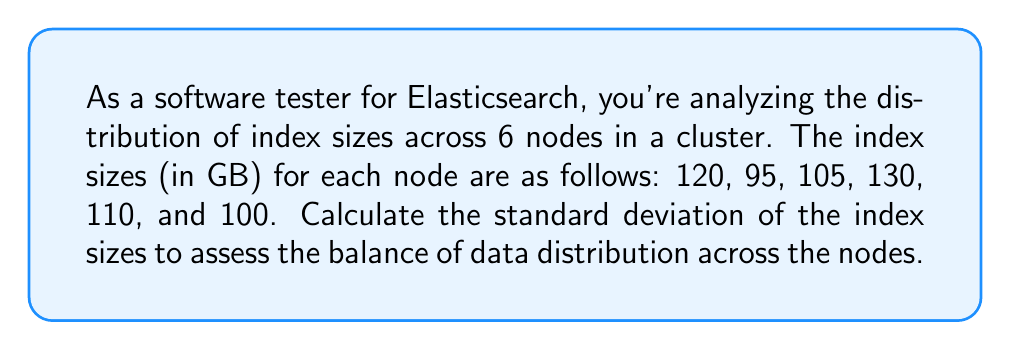Provide a solution to this math problem. To calculate the standard deviation, we'll follow these steps:

1. Calculate the mean (average) of the index sizes:
   $$\bar{x} = \frac{\sum_{i=1}^{n} x_i}{n} = \frac{120 + 95 + 105 + 130 + 110 + 100}{6} = \frac{660}{6} = 110$$

2. Calculate the squared differences from the mean:
   $$(120 - 110)^2 = 100$$
   $$(95 - 110)^2 = 225$$
   $$(105 - 110)^2 = 25$$
   $$(130 - 110)^2 = 400$$
   $$(110 - 110)^2 = 0$$
   $$(100 - 110)^2 = 100$$

3. Calculate the sum of squared differences:
   $$\sum_{i=1}^{n} (x_i - \bar{x})^2 = 100 + 225 + 25 + 400 + 0 + 100 = 850$$

4. Calculate the variance by dividing the sum of squared differences by (n-1):
   $$s^2 = \frac{\sum_{i=1}^{n} (x_i - \bar{x})^2}{n-1} = \frac{850}{5} = 170$$

5. Calculate the standard deviation by taking the square root of the variance:
   $$s = \sqrt{s^2} = \sqrt{170} \approx 13.04$$

Therefore, the standard deviation of the index sizes across the 6 Elasticsearch nodes is approximately 13.04 GB.
Answer: The standard deviation of the index sizes is approximately 13.04 GB. 